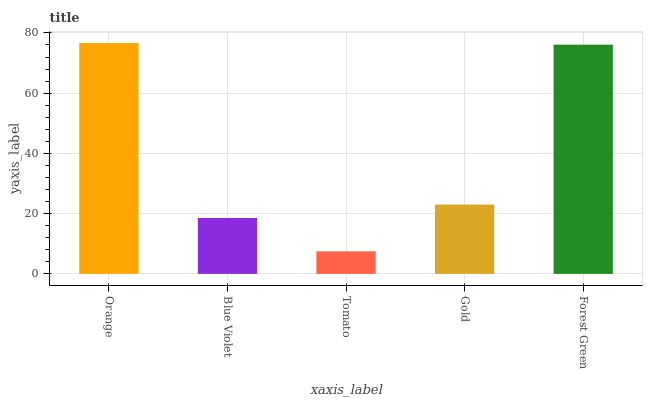Is Tomato the minimum?
Answer yes or no. Yes. Is Orange the maximum?
Answer yes or no. Yes. Is Blue Violet the minimum?
Answer yes or no. No. Is Blue Violet the maximum?
Answer yes or no. No. Is Orange greater than Blue Violet?
Answer yes or no. Yes. Is Blue Violet less than Orange?
Answer yes or no. Yes. Is Blue Violet greater than Orange?
Answer yes or no. No. Is Orange less than Blue Violet?
Answer yes or no. No. Is Gold the high median?
Answer yes or no. Yes. Is Gold the low median?
Answer yes or no. Yes. Is Blue Violet the high median?
Answer yes or no. No. Is Orange the low median?
Answer yes or no. No. 